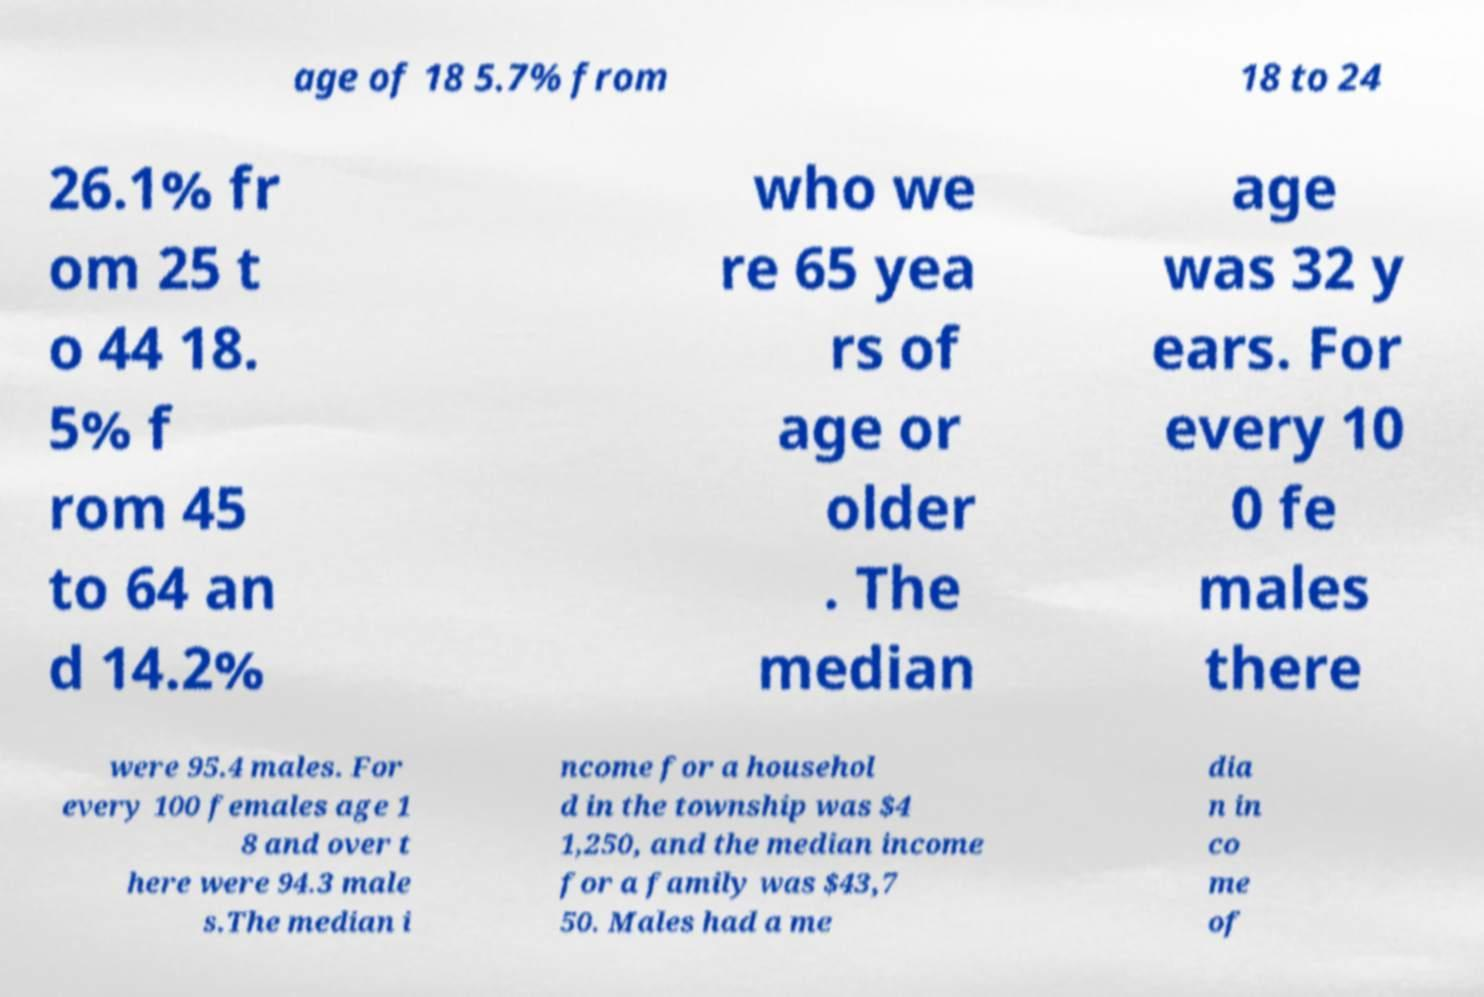I need the written content from this picture converted into text. Can you do that? age of 18 5.7% from 18 to 24 26.1% fr om 25 t o 44 18. 5% f rom 45 to 64 an d 14.2% who we re 65 yea rs of age or older . The median age was 32 y ears. For every 10 0 fe males there were 95.4 males. For every 100 females age 1 8 and over t here were 94.3 male s.The median i ncome for a househol d in the township was $4 1,250, and the median income for a family was $43,7 50. Males had a me dia n in co me of 